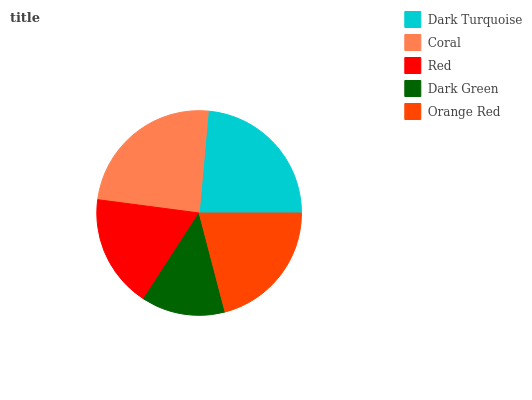Is Dark Green the minimum?
Answer yes or no. Yes. Is Coral the maximum?
Answer yes or no. Yes. Is Red the minimum?
Answer yes or no. No. Is Red the maximum?
Answer yes or no. No. Is Coral greater than Red?
Answer yes or no. Yes. Is Red less than Coral?
Answer yes or no. Yes. Is Red greater than Coral?
Answer yes or no. No. Is Coral less than Red?
Answer yes or no. No. Is Orange Red the high median?
Answer yes or no. Yes. Is Orange Red the low median?
Answer yes or no. Yes. Is Red the high median?
Answer yes or no. No. Is Dark Turquoise the low median?
Answer yes or no. No. 